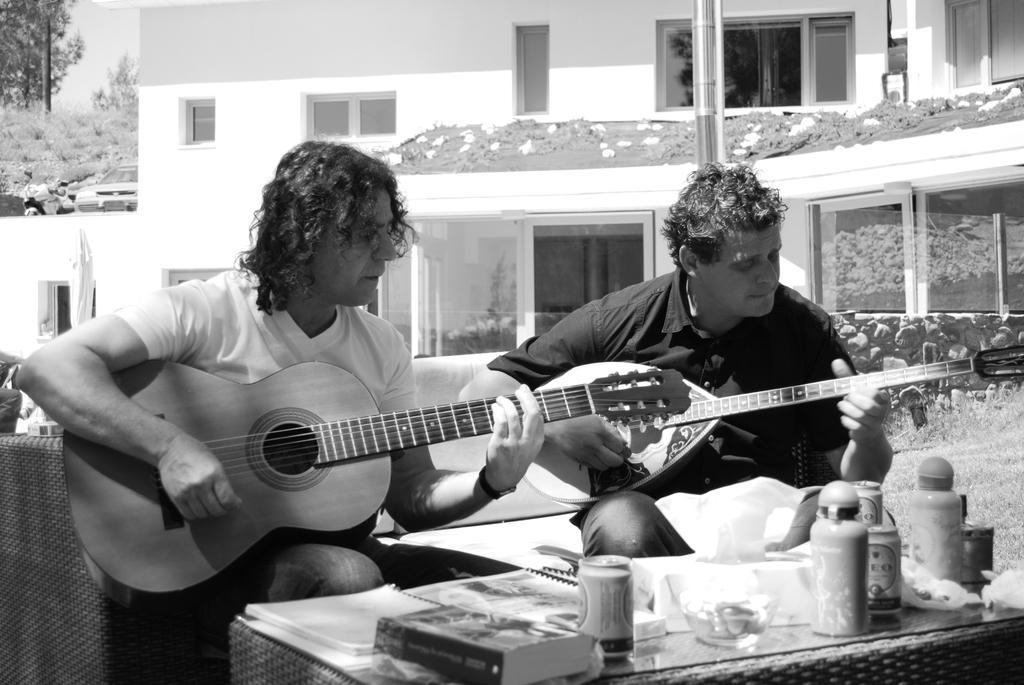Could you give a brief overview of what you see in this image? This picture is taken outside. There are two men sitting on sofas, besides a table. A man towards the left, he is wearing a white t shirt and playing a guitar. Besides him there is another person, he is wearing a black shirt and playing another guitar. On the table there are books, bottles and some jars. In the background there is a building. Towards the top left there are group of trees and a car. 